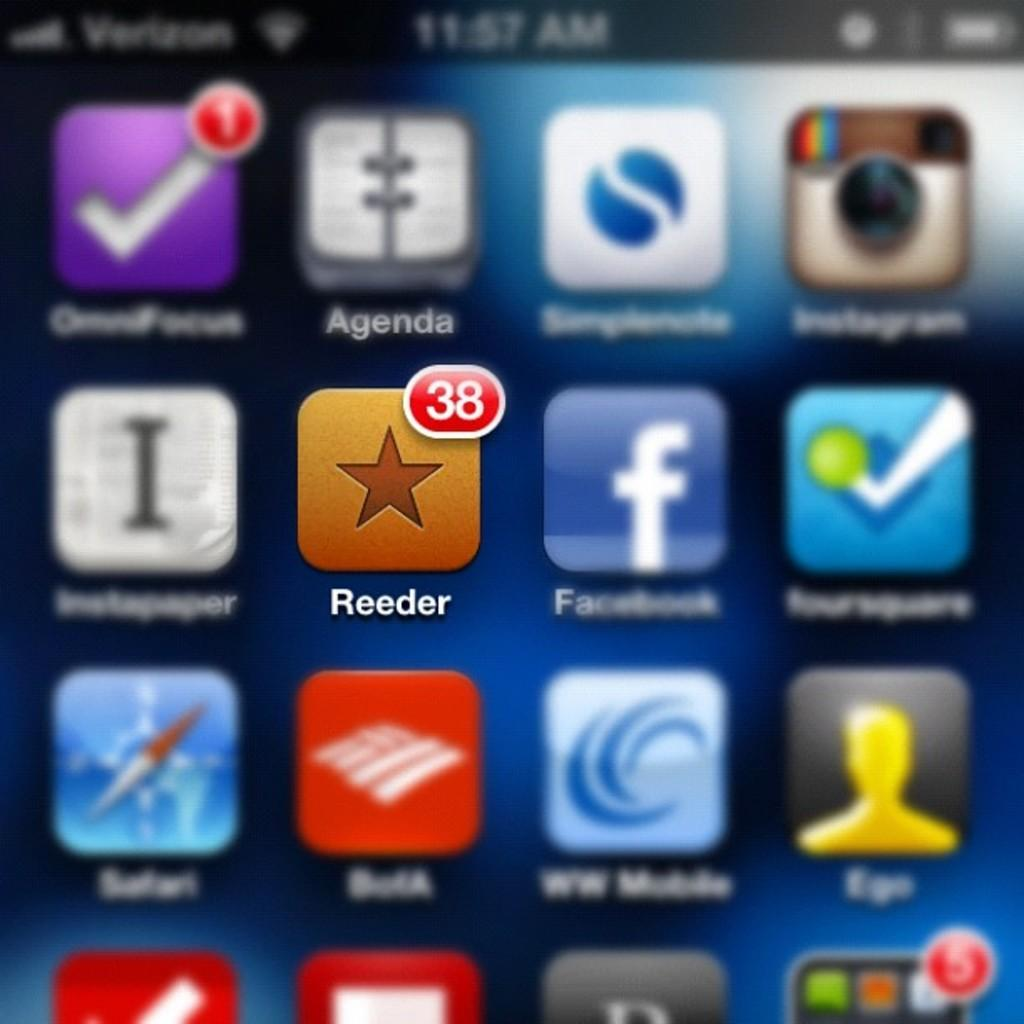What can be seen on the screen in the image? There are multiple apps visible on the screen. Can you describe the visibility of the apps on the screen? One app is clearly visible, while the others are blurred. What type of boat is visible in the image? There is no boat present in the image; it features a screen displaying multiple apps. 